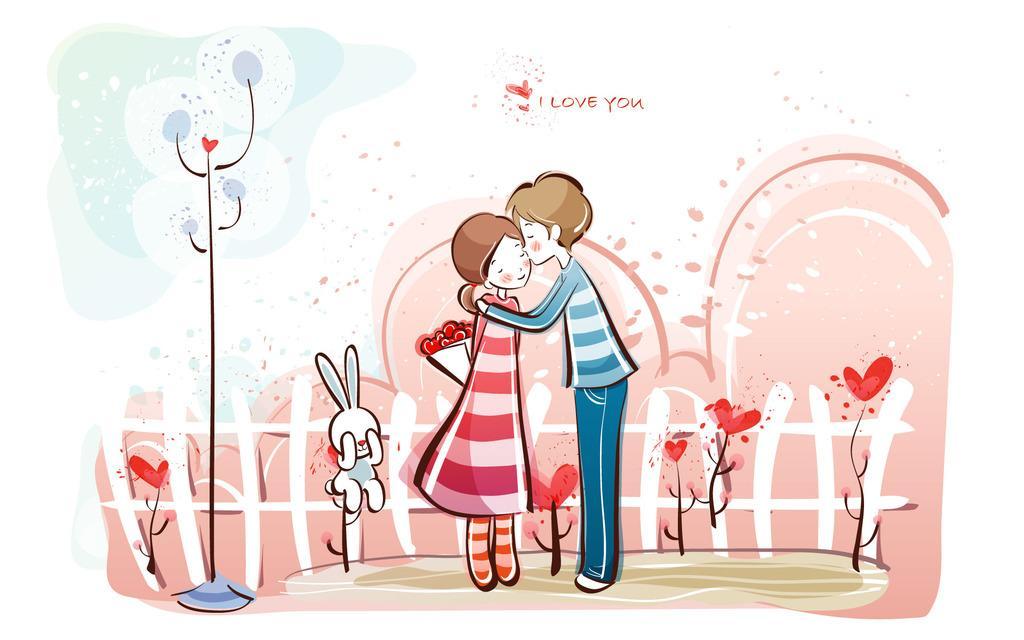Please provide a concise description of this image. In this image I can see cartoon picture of a man and a woman. I can also see some text and other things in this picture. 